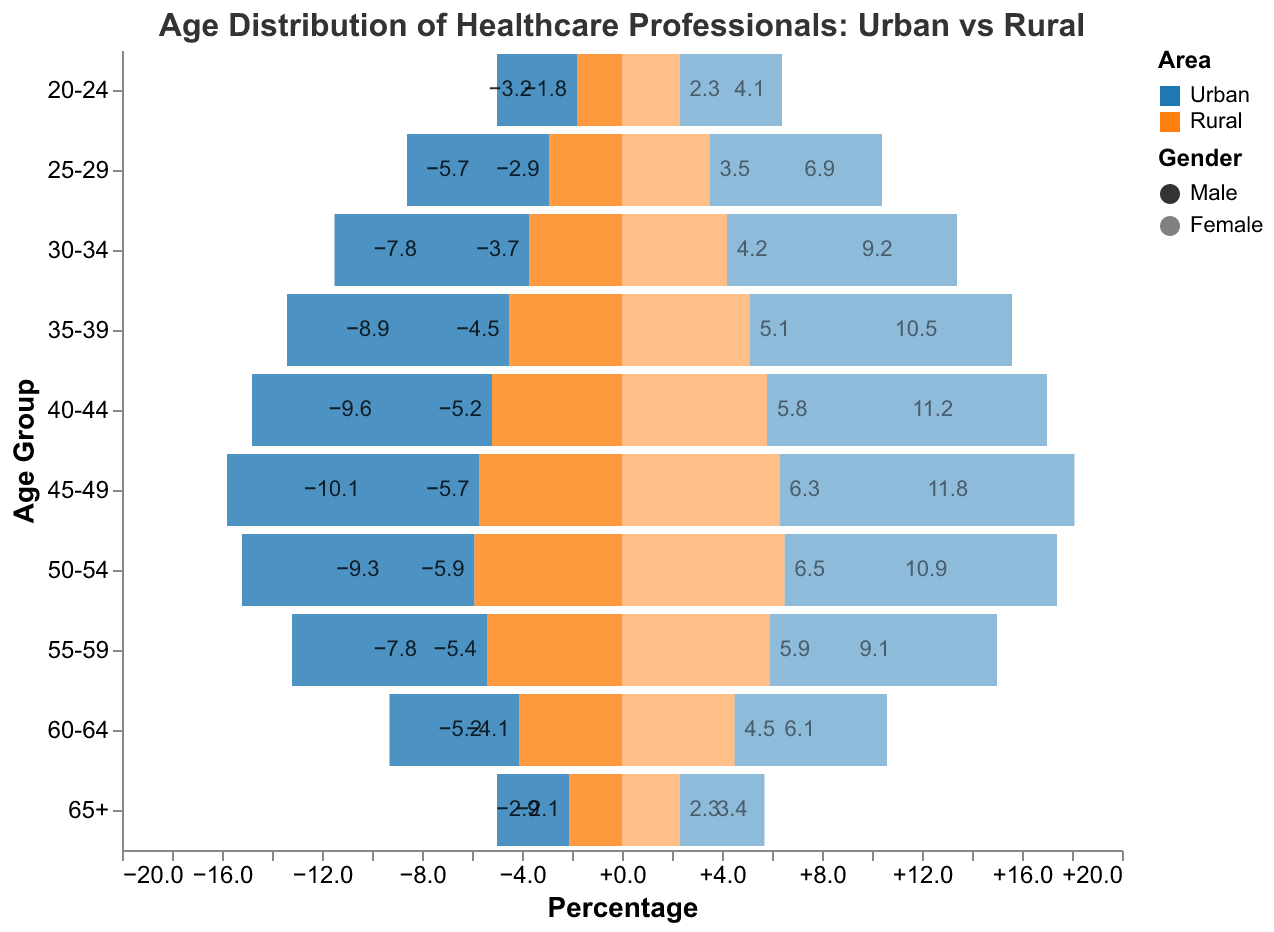What's the title of the figure? The title is usually at the top of the figure and summarizes the content. Here, it reads "Age Distribution of Healthcare Professionals: Urban vs Rural."
Answer: Age Distribution of Healthcare Professionals: Urban vs Rural How does the distribution of healthcare professionals aged 50-54 compare between urban and rural areas for both genders? Look at the "50-54" age group in the y-axis; Urban Male has 9.3%, Urban Female has 10.9%, Rural Male has 5.9%, and Rural Female has 6.5%.
Answer: Urban areas have higher percentages for both genders What age group has the highest percentage of rural male healthcare professionals? Check the bar lengths for Rural Male on the left side (negative values). The "50-54" age group is the highest with 5.9%.
Answer: 50-54 What is the percentage difference between urban and rural male healthcare professionals in the 40-44 age group? Urban Male has 9.6% and Rural Male has 5.2%. The difference is 9.6% - 5.2% = 4.4%.
Answer: 4.4% Which gender has more healthcare professionals in the 30-34 age group in urban areas? Compare the bar lengths for Urban Male (7.8%) and Urban Female (9.2%) in the "30-34" age group. Urban Female is higher.
Answer: Female In the 45-49 age group, how does the number of rural female healthcare professionals compare to rural males? For the "45-49" age group, Rural Female has 6.3% and Rural Male has 5.7%. Females have a slightly higher percentage by 0.6%.
Answer: Rural females have a higher percentage Which age group has the smallest difference between urban and rural female healthcare professionals? Compare differences for each age group. For "60-64," Urban Female is 6.1% and Rural Female is 4.5%, a difference of 1.6%, which is the smallest among all groups.
Answer: 60-64 What is the average percentage of urban female healthcare professionals across all age groups? Sum the percentages (4.1 + 6.9 + 9.2 + 10.5 + 11.2 + 11.8 + 10.9 + 9.1 + 6.1 + 3.4) = 83.2%, and divide by the 10 age groups. 83.2 / 10 = 8.32%.
Answer: 8.32% Which area has a higher representation of healthcare professionals aged 55-59: urban or rural? For the "55-59" age group, Urban Male has 7.8% and Urban Female has 9.1%. Rural Male has 5.4% and Rural Female has 5.9%. Urban representation is higher.
Answer: Urban How do urban female healthcare professionals compare across the age groups? Look at the right-side bars for Urban Female. Percentages increase from 4.1% (20-24) to 11.8% (45-49), then decrease steadily to 3.4% (65+).
Answer: Initially increase, peak at 45-49, then decrease 